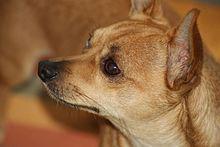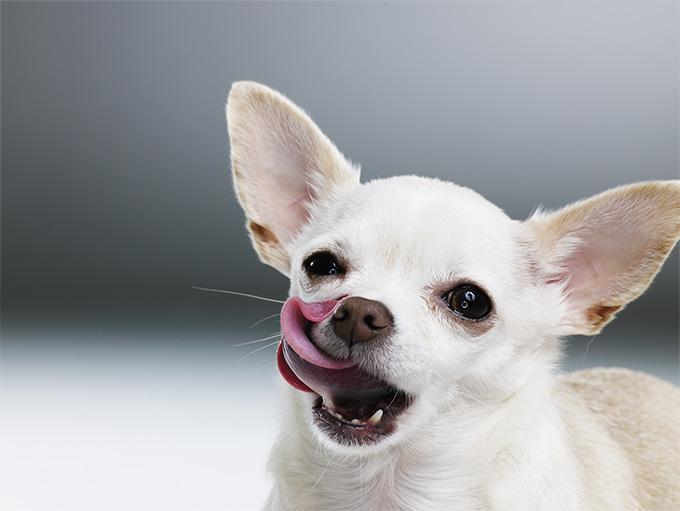The first image is the image on the left, the second image is the image on the right. For the images shown, is this caption "The dogs in the image on the right are sitting on grass." true? Answer yes or no. No. 